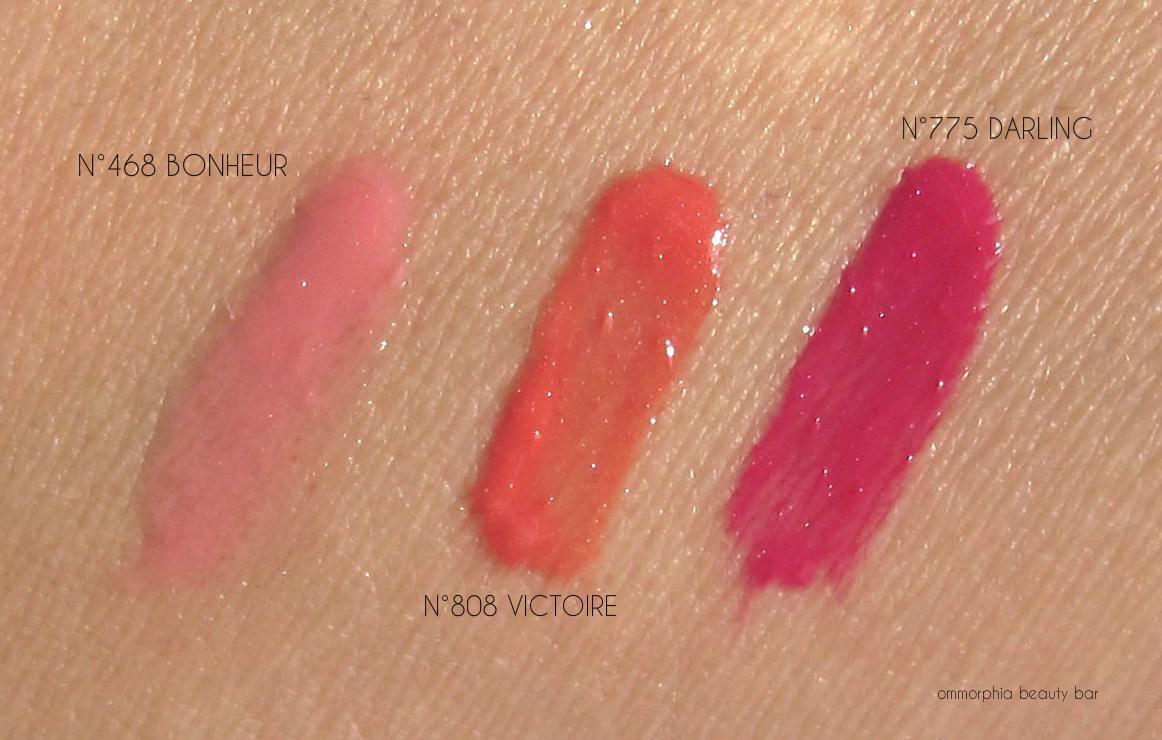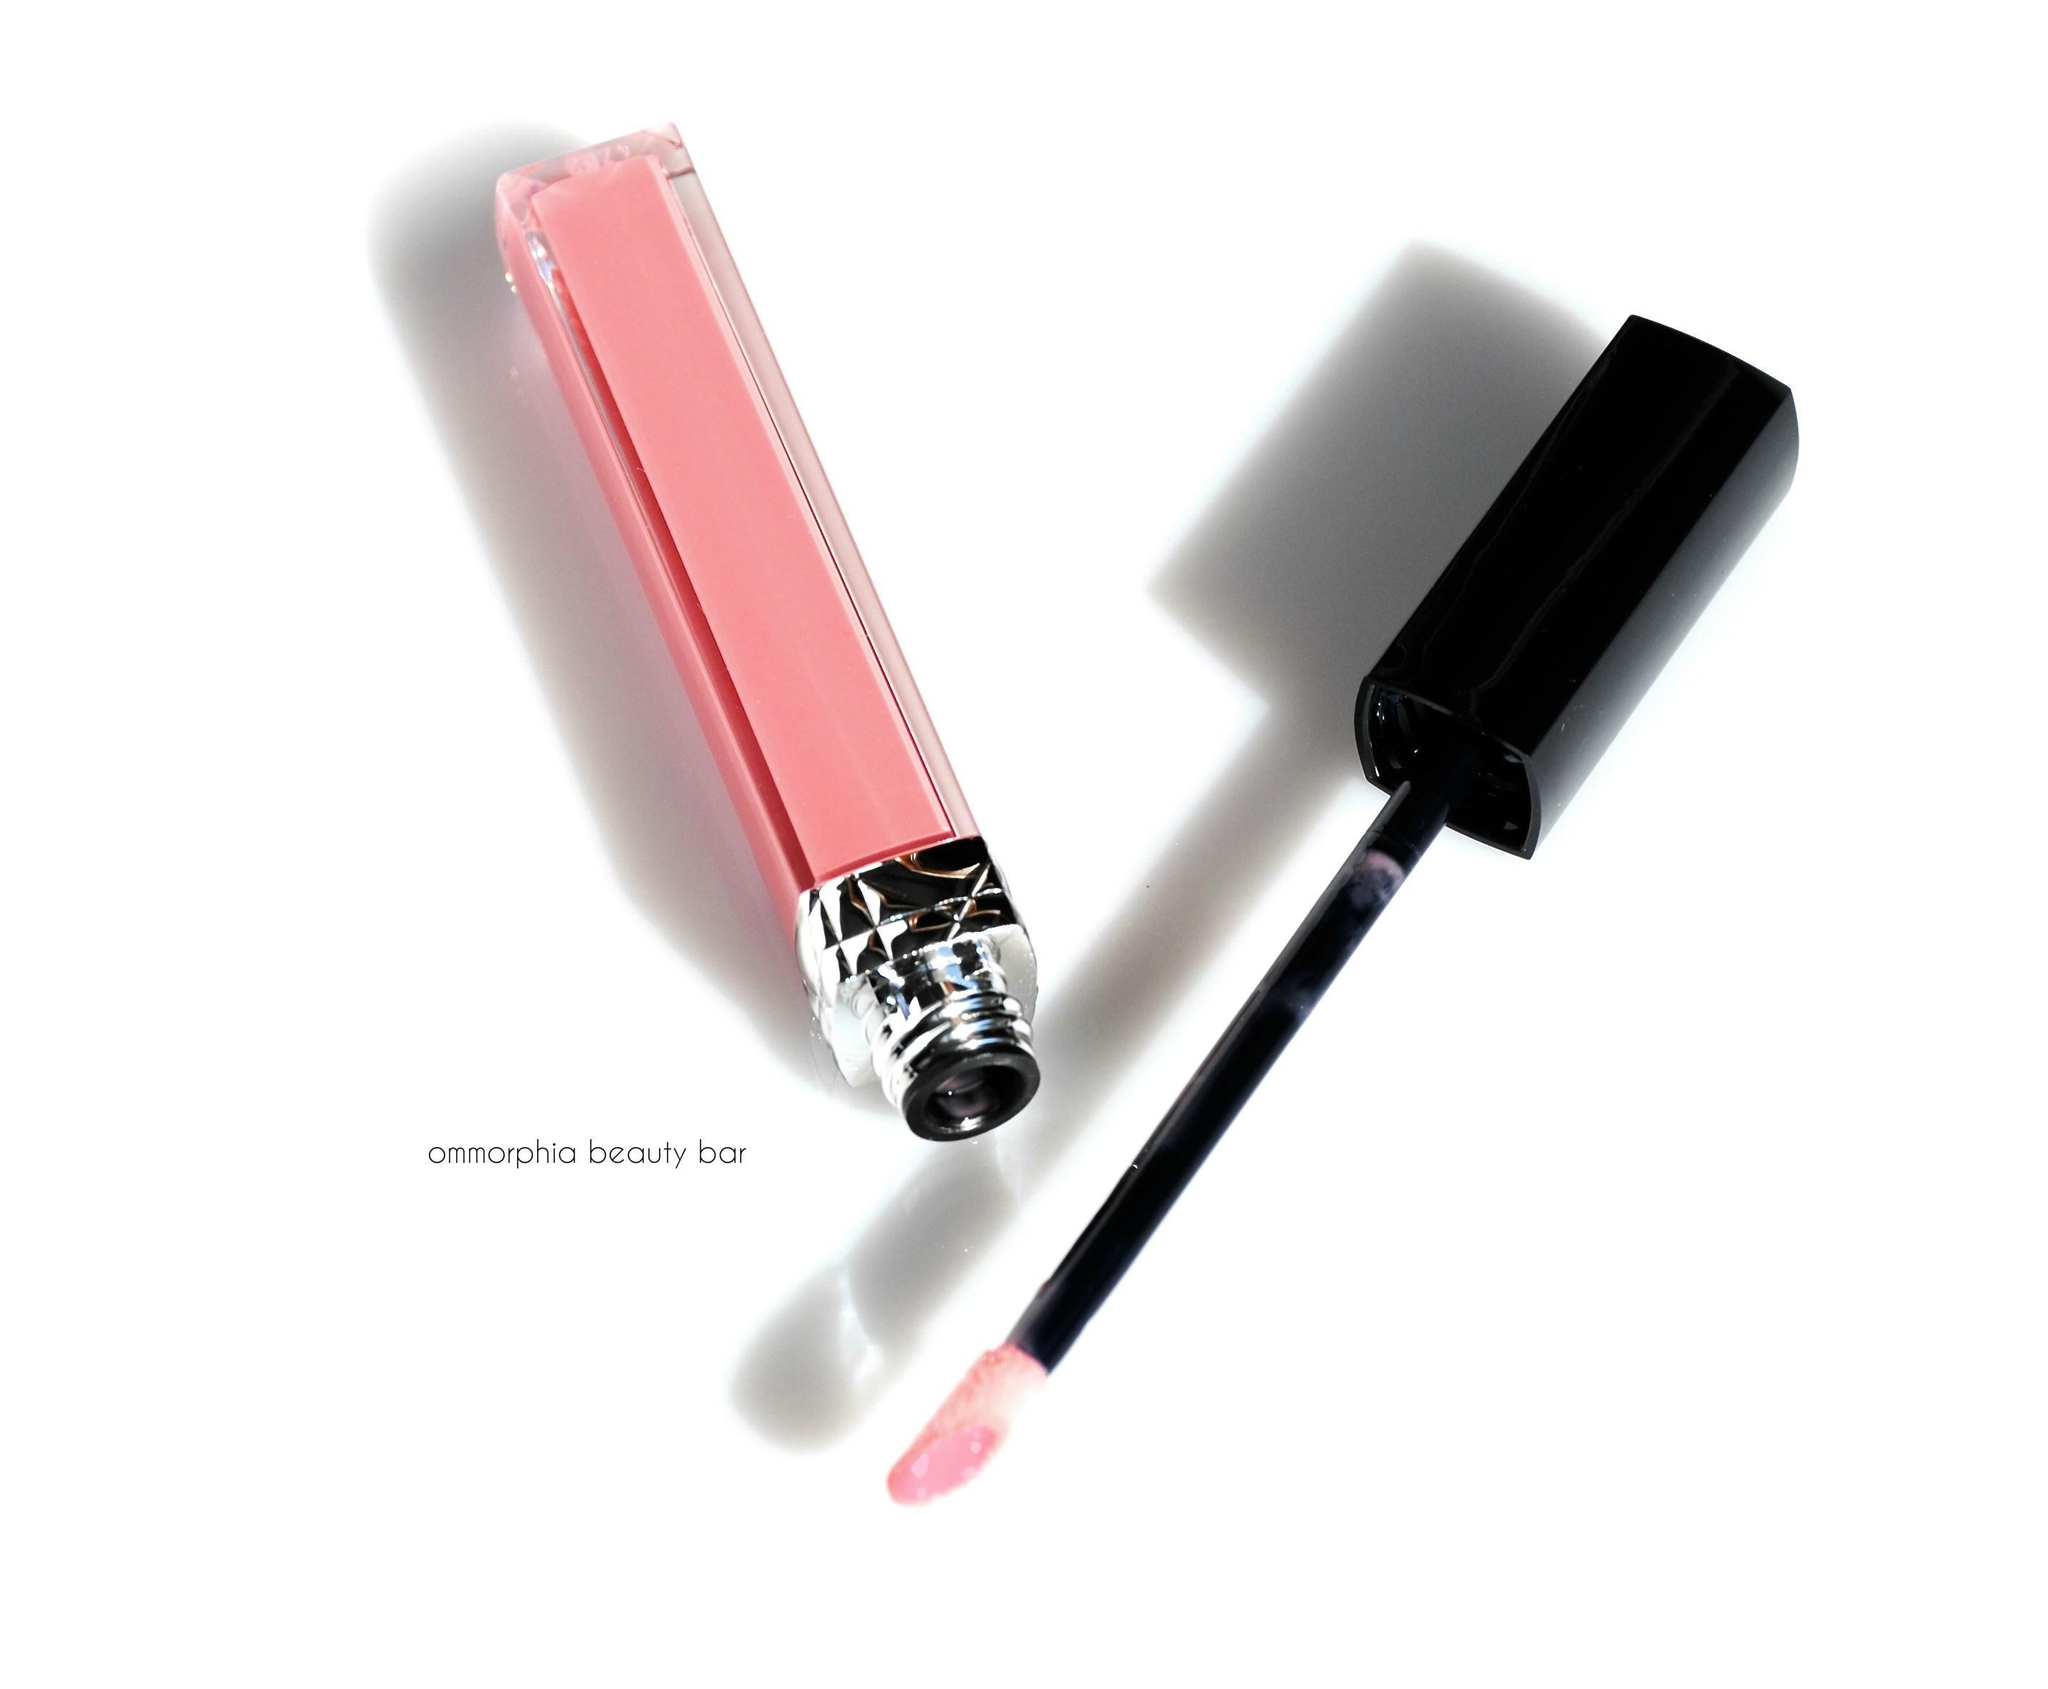The first image is the image on the left, the second image is the image on the right. Considering the images on both sides, is "Color swatches of lip products are on a person's skin." valid? Answer yes or no. Yes. The first image is the image on the left, the second image is the image on the right. Considering the images on both sides, is "At least one of the images includes streaks of lip gloss on someone's skin." valid? Answer yes or no. Yes. 